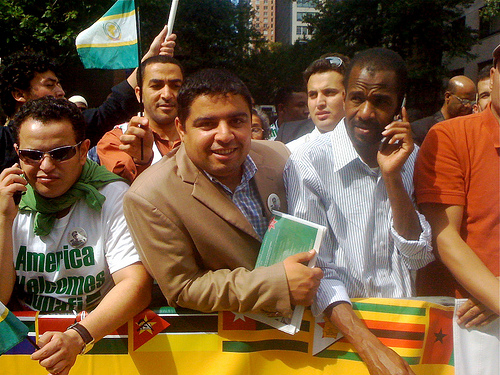How many flags are there? There appears to be at least three flags being held by individuals in the image. It is possible that additional flags may be present but not visible due to the angle or partial views. 